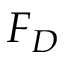<formula> <loc_0><loc_0><loc_500><loc_500>F _ { D }</formula> 